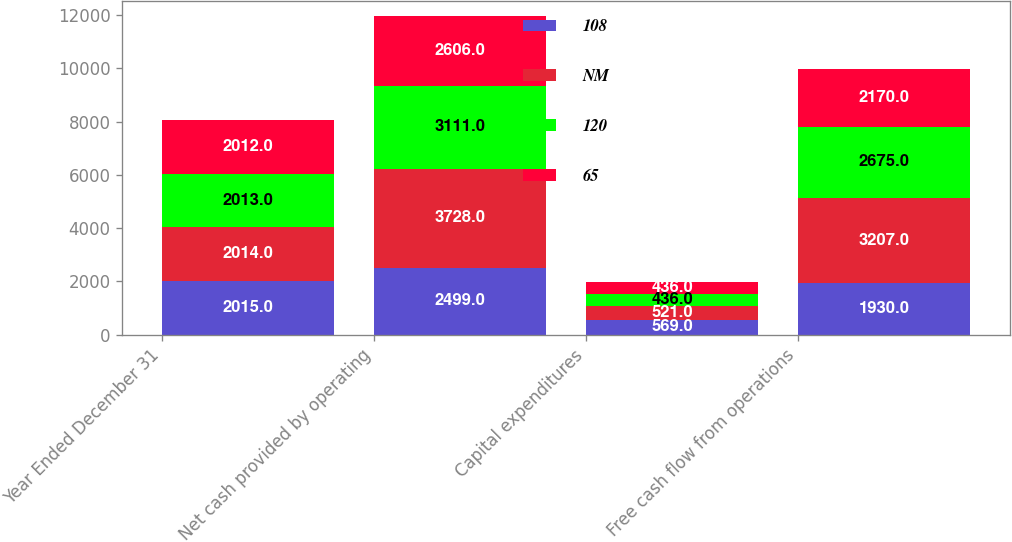Convert chart to OTSL. <chart><loc_0><loc_0><loc_500><loc_500><stacked_bar_chart><ecel><fcel>Year Ended December 31<fcel>Net cash provided by operating<fcel>Capital expenditures<fcel>Free cash flow from operations<nl><fcel>108<fcel>2015<fcel>2499<fcel>569<fcel>1930<nl><fcel>NM<fcel>2014<fcel>3728<fcel>521<fcel>3207<nl><fcel>120<fcel>2013<fcel>3111<fcel>436<fcel>2675<nl><fcel>65<fcel>2012<fcel>2606<fcel>436<fcel>2170<nl></chart> 